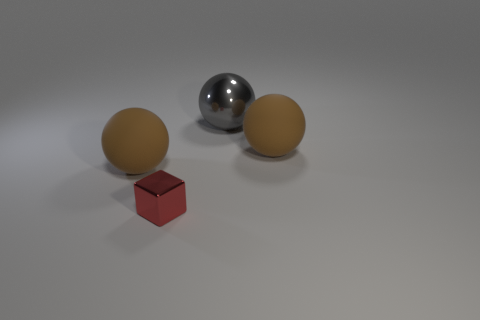Add 1 large brown rubber objects. How many objects exist? 5 Subtract all balls. How many objects are left? 1 Subtract 0 purple blocks. How many objects are left? 4 Subtract all red metallic things. Subtract all brown blocks. How many objects are left? 3 Add 2 large metallic balls. How many large metallic balls are left? 3 Add 3 tiny metallic cylinders. How many tiny metallic cylinders exist? 3 